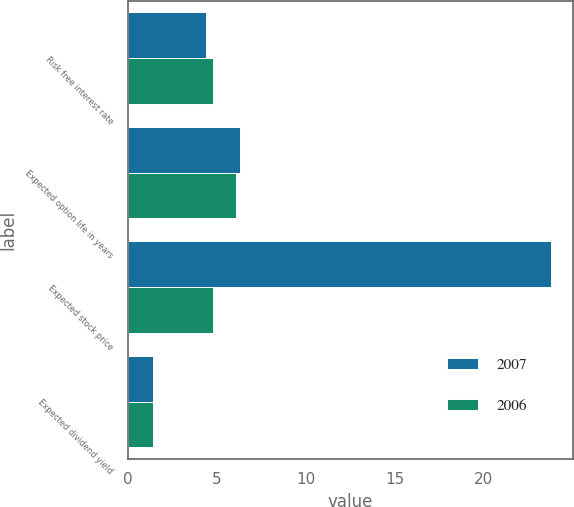<chart> <loc_0><loc_0><loc_500><loc_500><stacked_bar_chart><ecel><fcel>Risk free interest rate<fcel>Expected option life in years<fcel>Expected stock price<fcel>Expected dividend yield<nl><fcel>2007<fcel>4.4<fcel>6.3<fcel>23.8<fcel>1.4<nl><fcel>2006<fcel>4.8<fcel>6.1<fcel>4.8<fcel>1.4<nl></chart> 